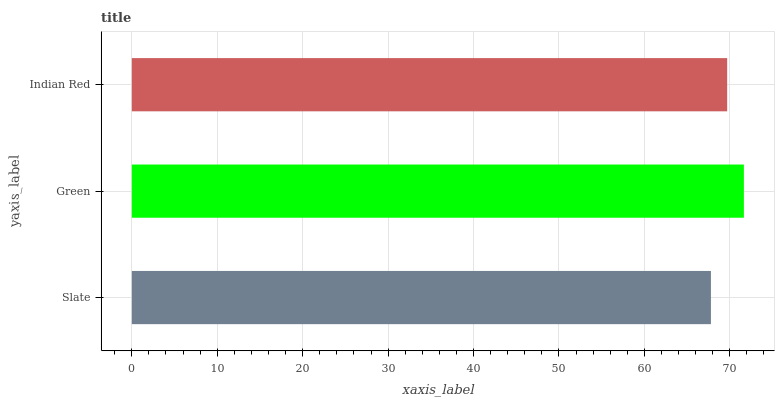Is Slate the minimum?
Answer yes or no. Yes. Is Green the maximum?
Answer yes or no. Yes. Is Indian Red the minimum?
Answer yes or no. No. Is Indian Red the maximum?
Answer yes or no. No. Is Green greater than Indian Red?
Answer yes or no. Yes. Is Indian Red less than Green?
Answer yes or no. Yes. Is Indian Red greater than Green?
Answer yes or no. No. Is Green less than Indian Red?
Answer yes or no. No. Is Indian Red the high median?
Answer yes or no. Yes. Is Indian Red the low median?
Answer yes or no. Yes. Is Slate the high median?
Answer yes or no. No. Is Slate the low median?
Answer yes or no. No. 